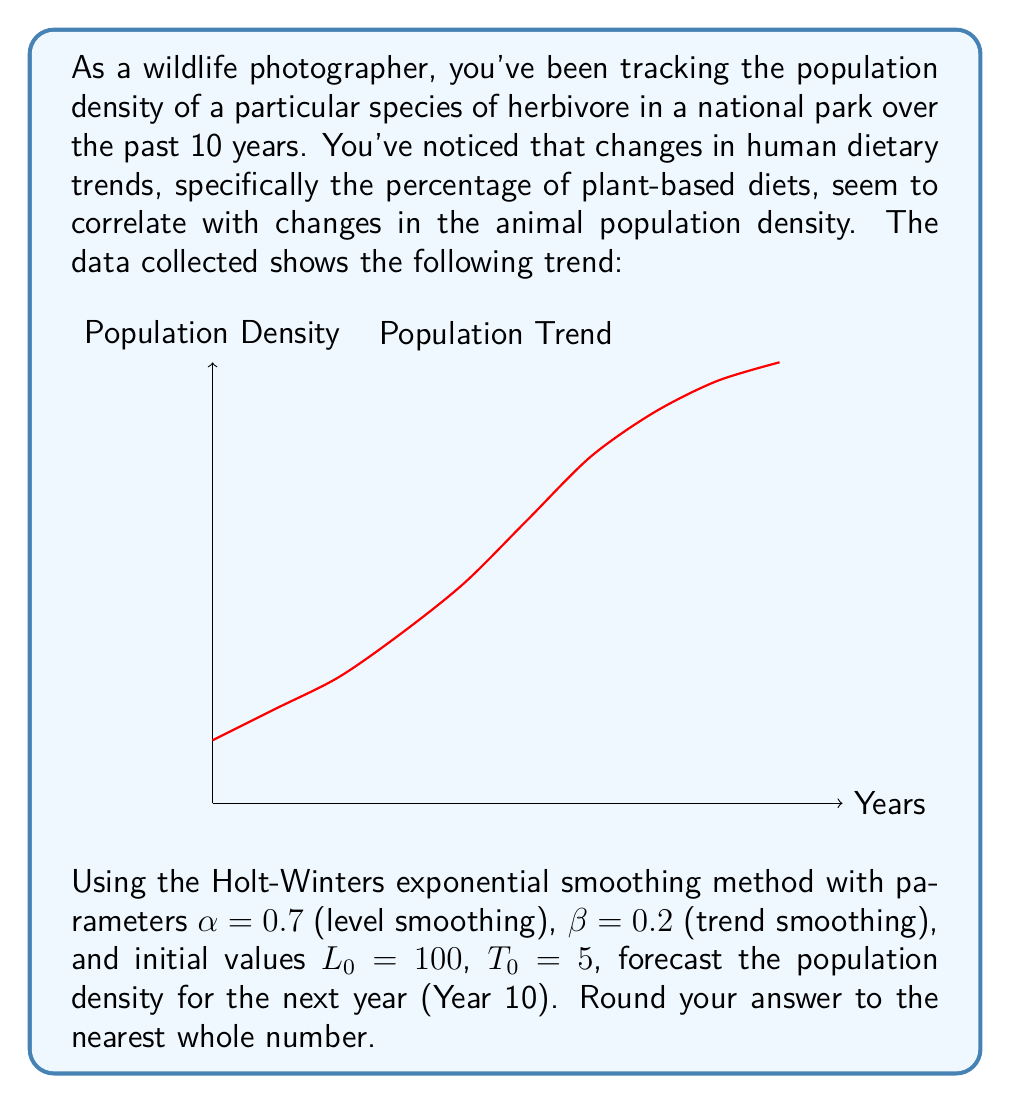Teach me how to tackle this problem. To solve this problem, we'll use the Holt-Winters exponential smoothing method without seasonality (also known as double exponential smoothing). The formulas are:

1) Level: $L_t = \alpha Y_t + (1-\alpha)(L_{t-1} + T_{t-1})$
2) Trend: $T_t = \beta(L_t - L_{t-1}) + (1-\beta)T_{t-1}$
3) Forecast: $F_{t+h} = L_t + hT_t$

Where:
$L_t$ is the level at time t
$T_t$ is the trend at time t
$Y_t$ is the observed value at time t
$\alpha$ and $\beta$ are smoothing parameters
$h$ is the number of periods ahead to forecast

Given:
$\alpha = 0.7$, $\beta = 0.2$, $L_0 = 100$, $T_0 = 5$

Let's calculate for each year:

Year 1:
$L_1 = 0.7(105) + (1-0.7)(100+5) = 103.5$
$T_1 = 0.2(103.5-100) + (1-0.2)(5) = 4.7$

Year 2:
$L_2 = 0.7(112) + (1-0.7)(103.5+4.7) = 109.56$
$T_2 = 0.2(109.56-103.5) + (1-0.2)(4.7) = 5.012$

...

Continuing this process for all 9 years, we get:

Year 9:
$L_9 = 206.0276$
$T_9 = 19.7055$

Now, to forecast for Year 10:

$F_{10} = L_9 + T_9 = 206.0276 + 19.7055 = 225.7331$

Rounding to the nearest whole number: 226
Answer: 226 